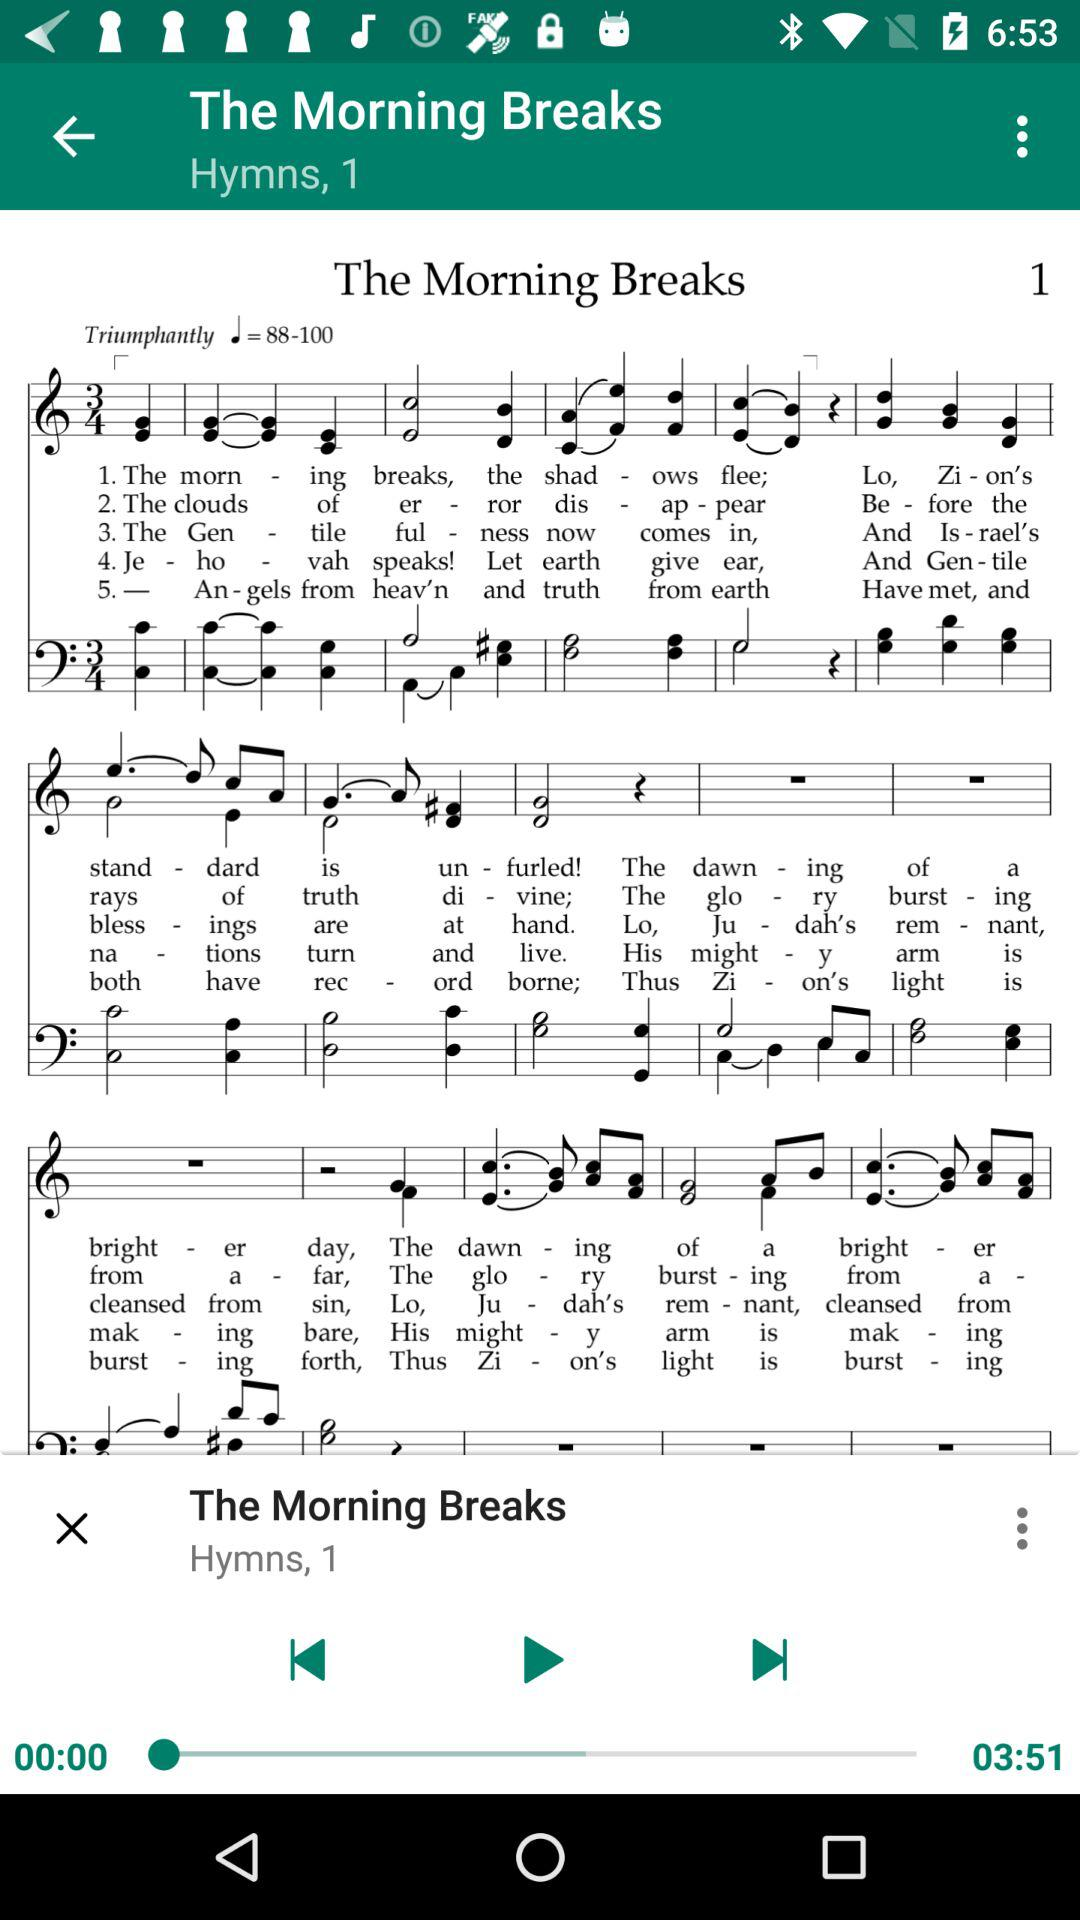What is the name of the "Hymns, 1"? The name of the "Hymns, 1" is "The Morning Breaks". 